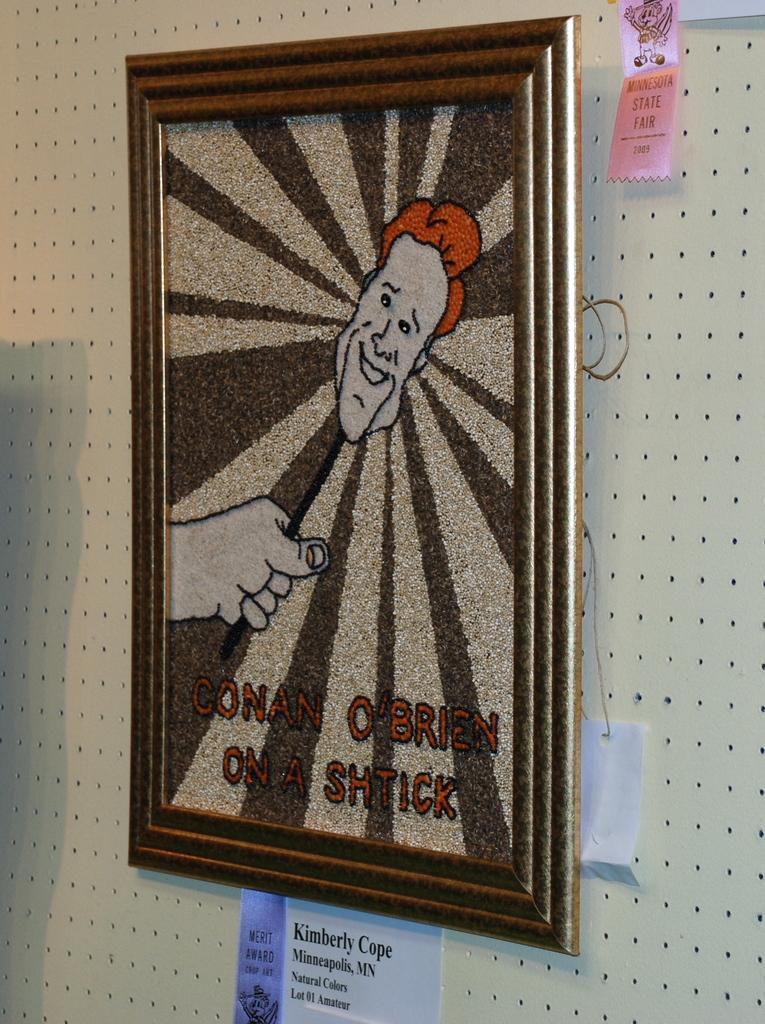<image>
Create a compact narrative representing the image presented. A glittery painting with conen o brien on a shtick (play on words because his head is on a stick.) 